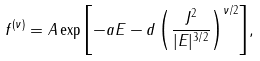Convert formula to latex. <formula><loc_0><loc_0><loc_500><loc_500>f ^ { ( \nu ) } = A \exp { \left [ - a E - d \left ( \frac { J ^ { 2 } } { | E | ^ { 3 / 2 } } \right ) ^ { \nu / 2 } \right ] } ,</formula> 